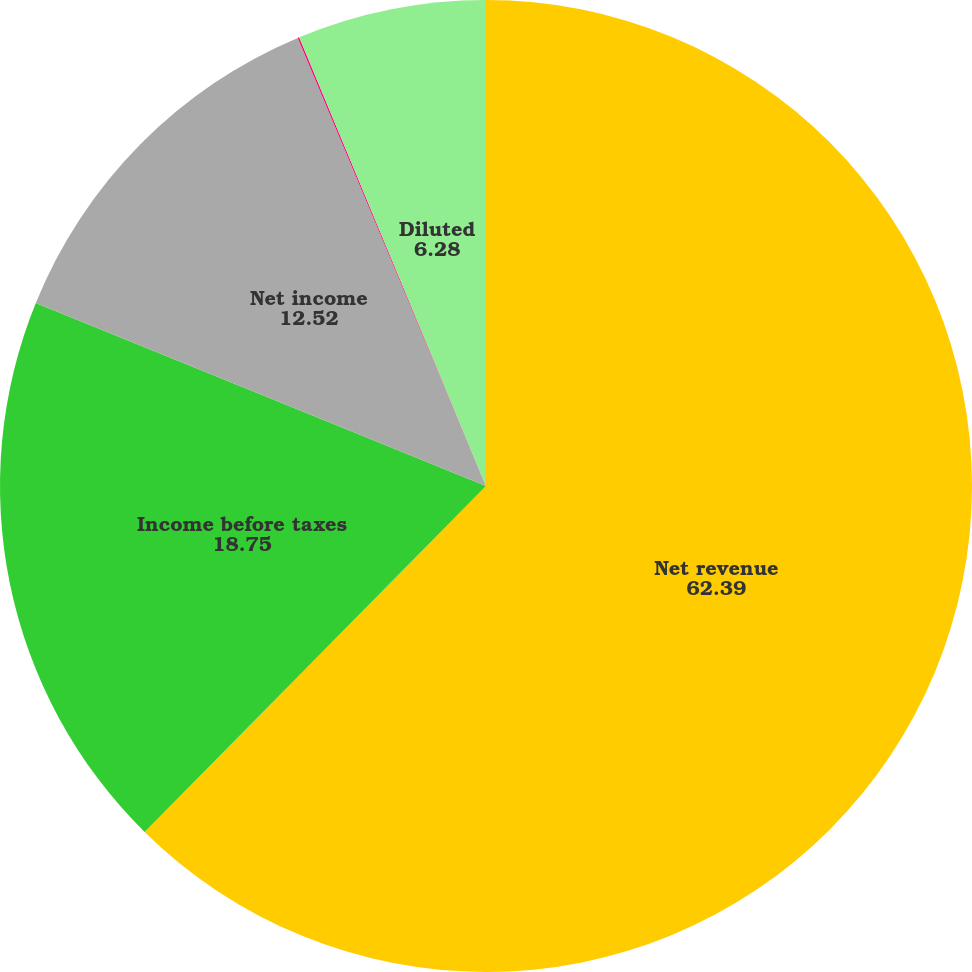<chart> <loc_0><loc_0><loc_500><loc_500><pie_chart><fcel>Net revenue<fcel>Income before taxes<fcel>Net income<fcel>Basic<fcel>Diluted<nl><fcel>62.39%<fcel>18.75%<fcel>12.52%<fcel>0.05%<fcel>6.28%<nl></chart> 